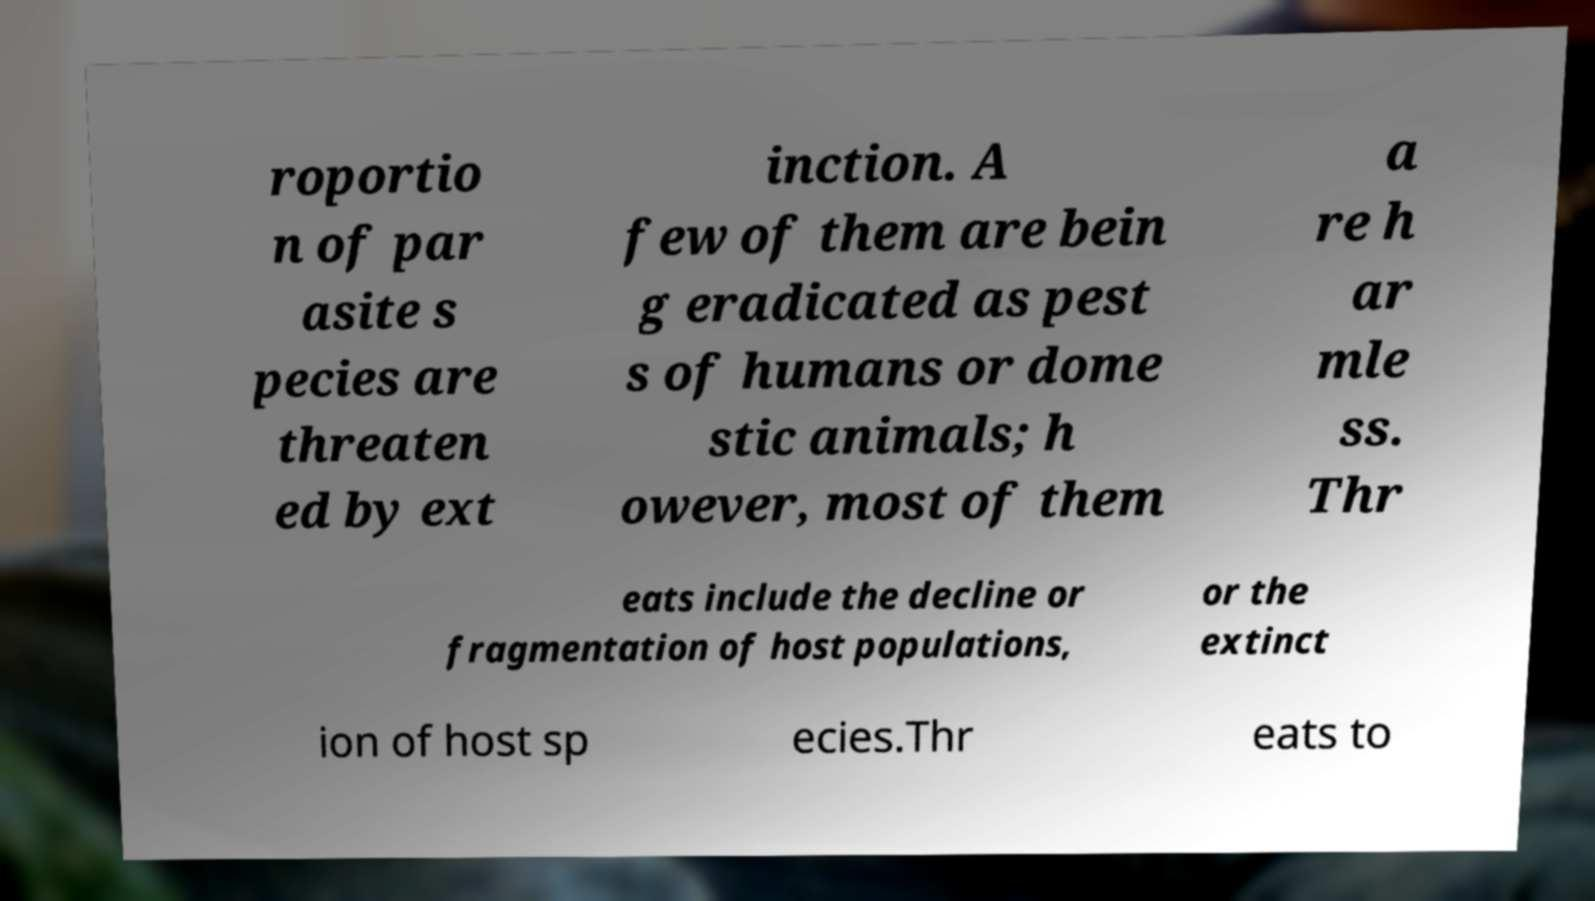Can you read and provide the text displayed in the image?This photo seems to have some interesting text. Can you extract and type it out for me? roportio n of par asite s pecies are threaten ed by ext inction. A few of them are bein g eradicated as pest s of humans or dome stic animals; h owever, most of them a re h ar mle ss. Thr eats include the decline or fragmentation of host populations, or the extinct ion of host sp ecies.Thr eats to 